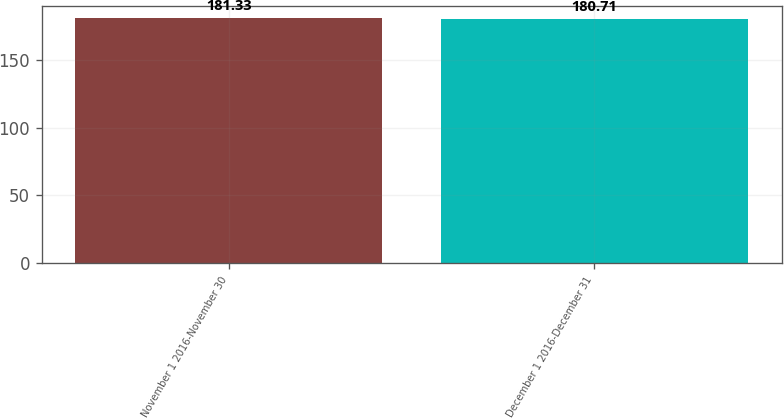Convert chart. <chart><loc_0><loc_0><loc_500><loc_500><bar_chart><fcel>November 1 2016-November 30<fcel>December 1 2016-December 31<nl><fcel>181.33<fcel>180.71<nl></chart> 